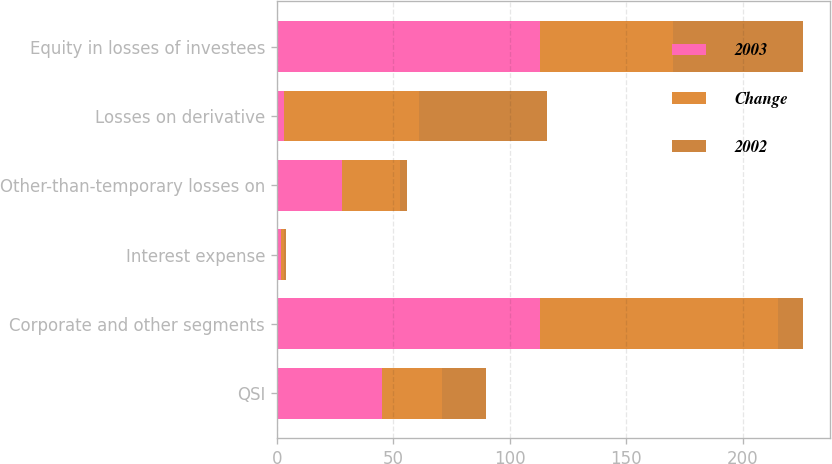<chart> <loc_0><loc_0><loc_500><loc_500><stacked_bar_chart><ecel><fcel>QSI<fcel>Corporate and other segments<fcel>Interest expense<fcel>Other-than-temporary losses on<fcel>Losses on derivative<fcel>Equity in losses of investees<nl><fcel>2003<fcel>45<fcel>113<fcel>2<fcel>28<fcel>3<fcel>113<nl><fcel>Change<fcel>26<fcel>102<fcel>1<fcel>25<fcel>58<fcel>57<nl><fcel>2002<fcel>19<fcel>11<fcel>1<fcel>3<fcel>55<fcel>56<nl></chart> 